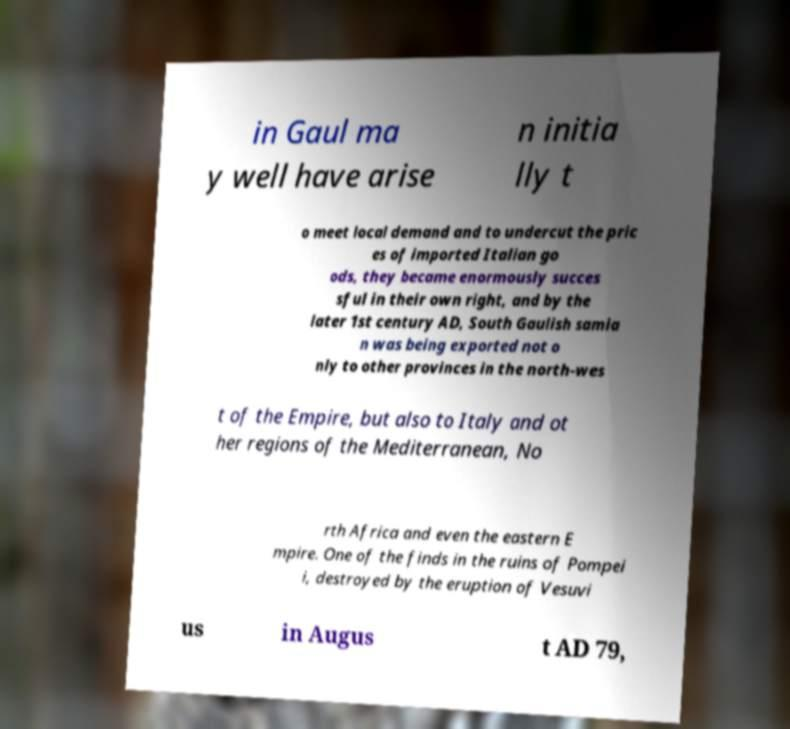Could you extract and type out the text from this image? in Gaul ma y well have arise n initia lly t o meet local demand and to undercut the pric es of imported Italian go ods, they became enormously succes sful in their own right, and by the later 1st century AD, South Gaulish samia n was being exported not o nly to other provinces in the north-wes t of the Empire, but also to Italy and ot her regions of the Mediterranean, No rth Africa and even the eastern E mpire. One of the finds in the ruins of Pompei i, destroyed by the eruption of Vesuvi us in Augus t AD 79, 